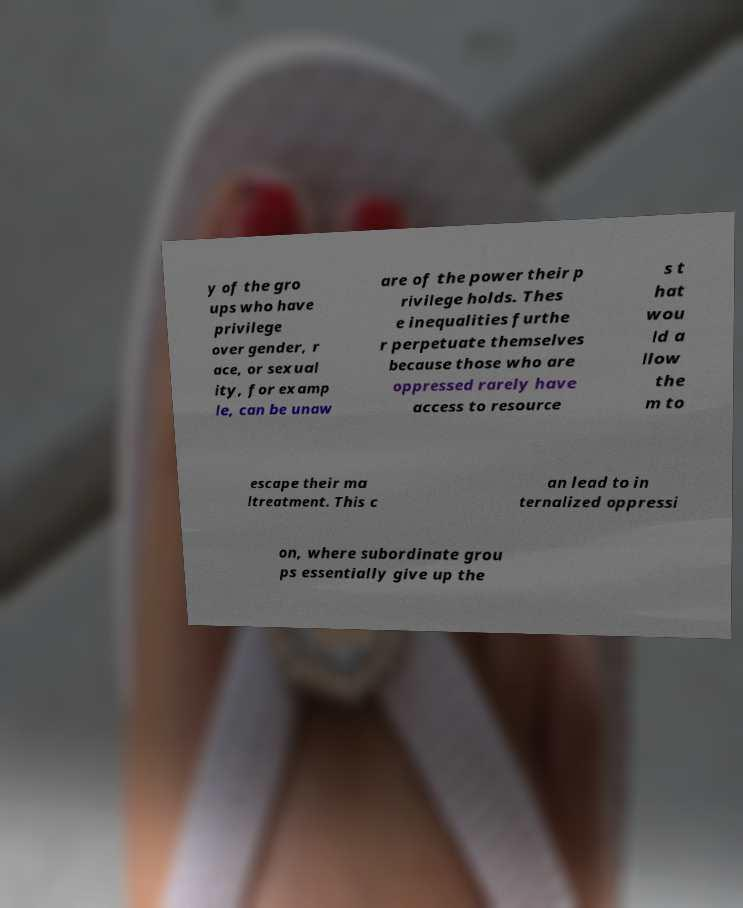I need the written content from this picture converted into text. Can you do that? y of the gro ups who have privilege over gender, r ace, or sexual ity, for examp le, can be unaw are of the power their p rivilege holds. Thes e inequalities furthe r perpetuate themselves because those who are oppressed rarely have access to resource s t hat wou ld a llow the m to escape their ma ltreatment. This c an lead to in ternalized oppressi on, where subordinate grou ps essentially give up the 